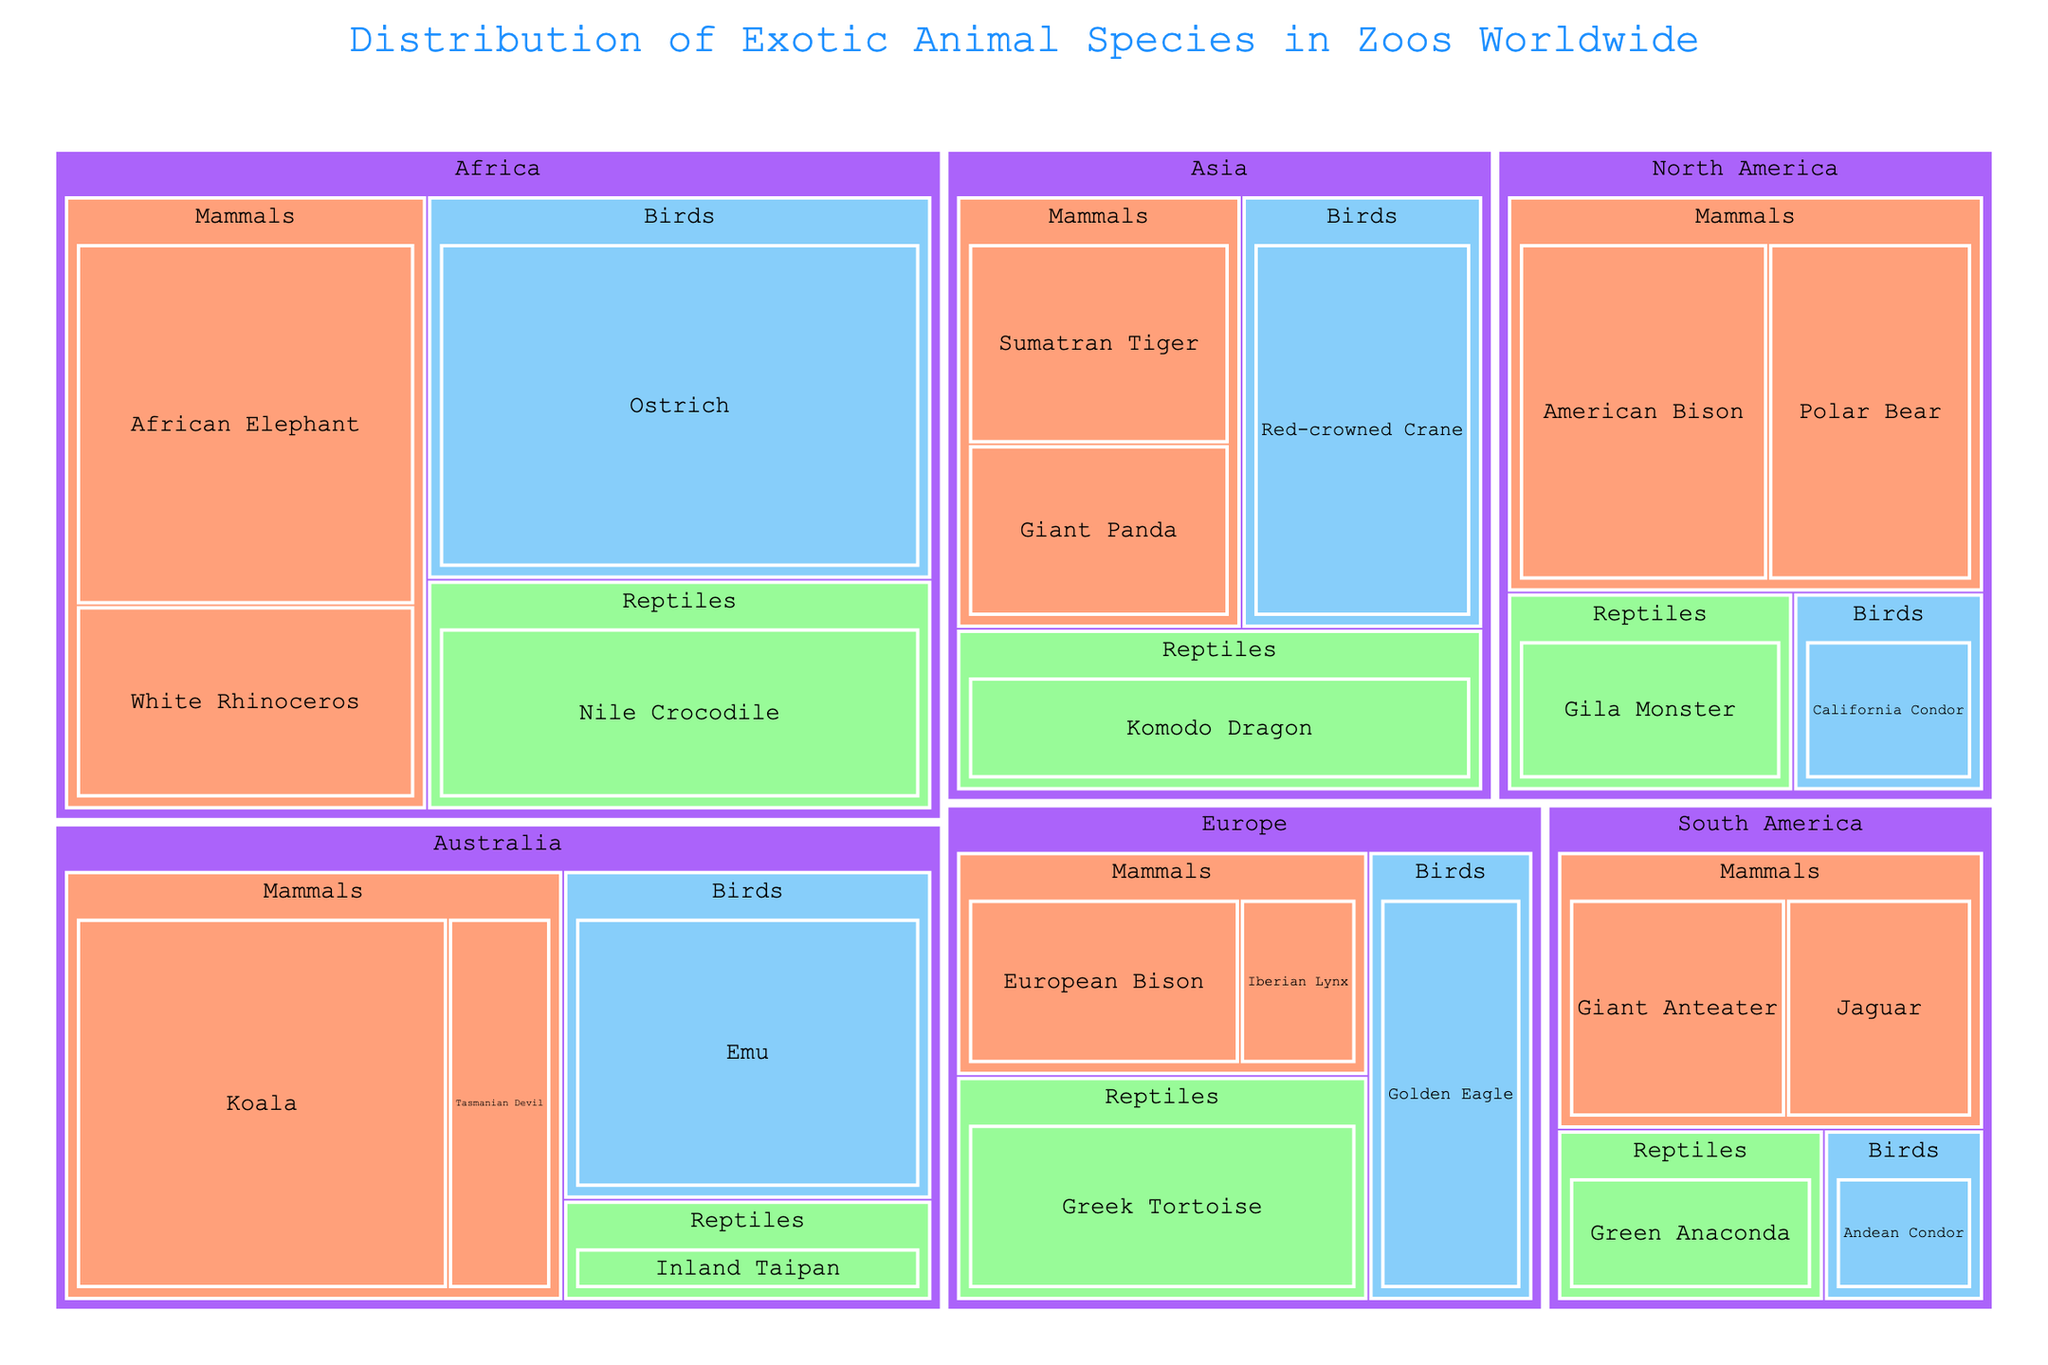what is the title of the treemap? The title is usually located at the top of the treemap and summarizes the main focus of the visualization.
Answer: Distribution of Exotic Animal Species in Zoos Worldwide Which continent has the most species of mammals represented in zoos? Look for the continent with the largest colored section representing mammals (orange color) in the treemap.
Answer: Australia Which exotic animal species has the highest count in zoos worldwide? Identify the species represented by the largest individual box within the treemap.
Answer: Ostrich What's the difference in the count of Koalas and Tasmanian Devils in Australian zoos? Identify the counts for both Koalas and Tasmanian Devils in the Australia section, then subtract the count of Tasmanian Devils from the count of Koalas.
Answer: 130 Which animal class has the most evenly distributed representation across all continents? Check for the animal class with similarly sized boxes across different continents within the treemap.
Answer: Mammals In North America, which animal class is represented in the fewest number of species? Within the North America section, identify the smallest colored section representing an animal class.
Answer: Birds Compare the count of Giant Pandas and Komodo Dragons in Asian zoos. Which one has a higher count? Identify the counts for both the Giant Pandas and Komodo Dragons in the Asia section, then compare which is higher.
Answer: Komodo Dragon Which continent has the smallest diversity of exotic animal species in zoos? Examine the number of different species boxes under each continent section.
Answer: Europe Add up the count of species from the Reptiles class in Asia and Europe. What is the total count? Identify the counts for each species within Reptiles in Asia and Europe sections, then sum them up (Komodo Dragon and Greek Tortoise).
Answer: 190 Considering all continents, which animal class overall is least represented in zoos worldwide? Compare the total face area of different colored sections representing different animal classes across all continents.
Answer: Birds 